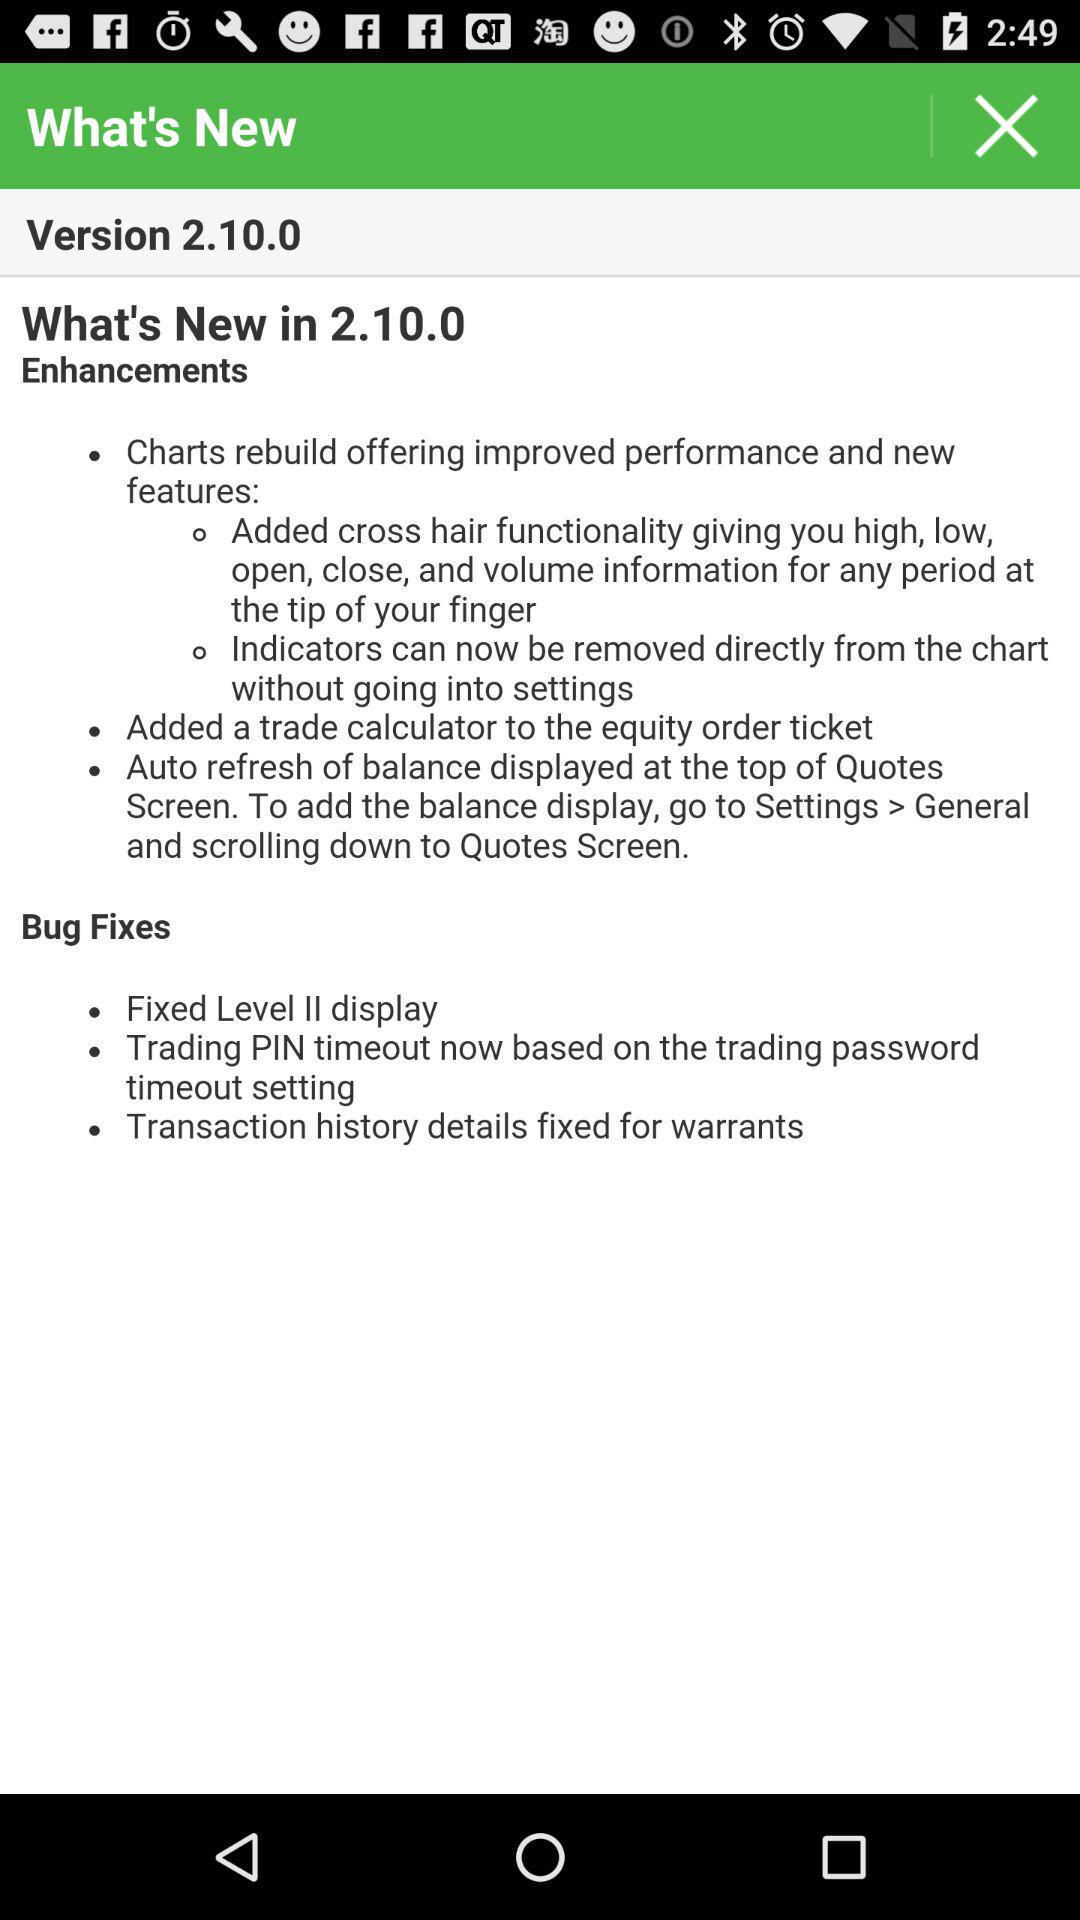Which is the given version? The given version is 2.10.0. 